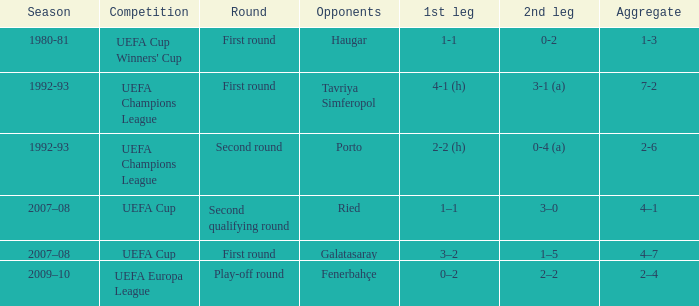What's the opening round where the competitors are galatasaray? 3–2. 